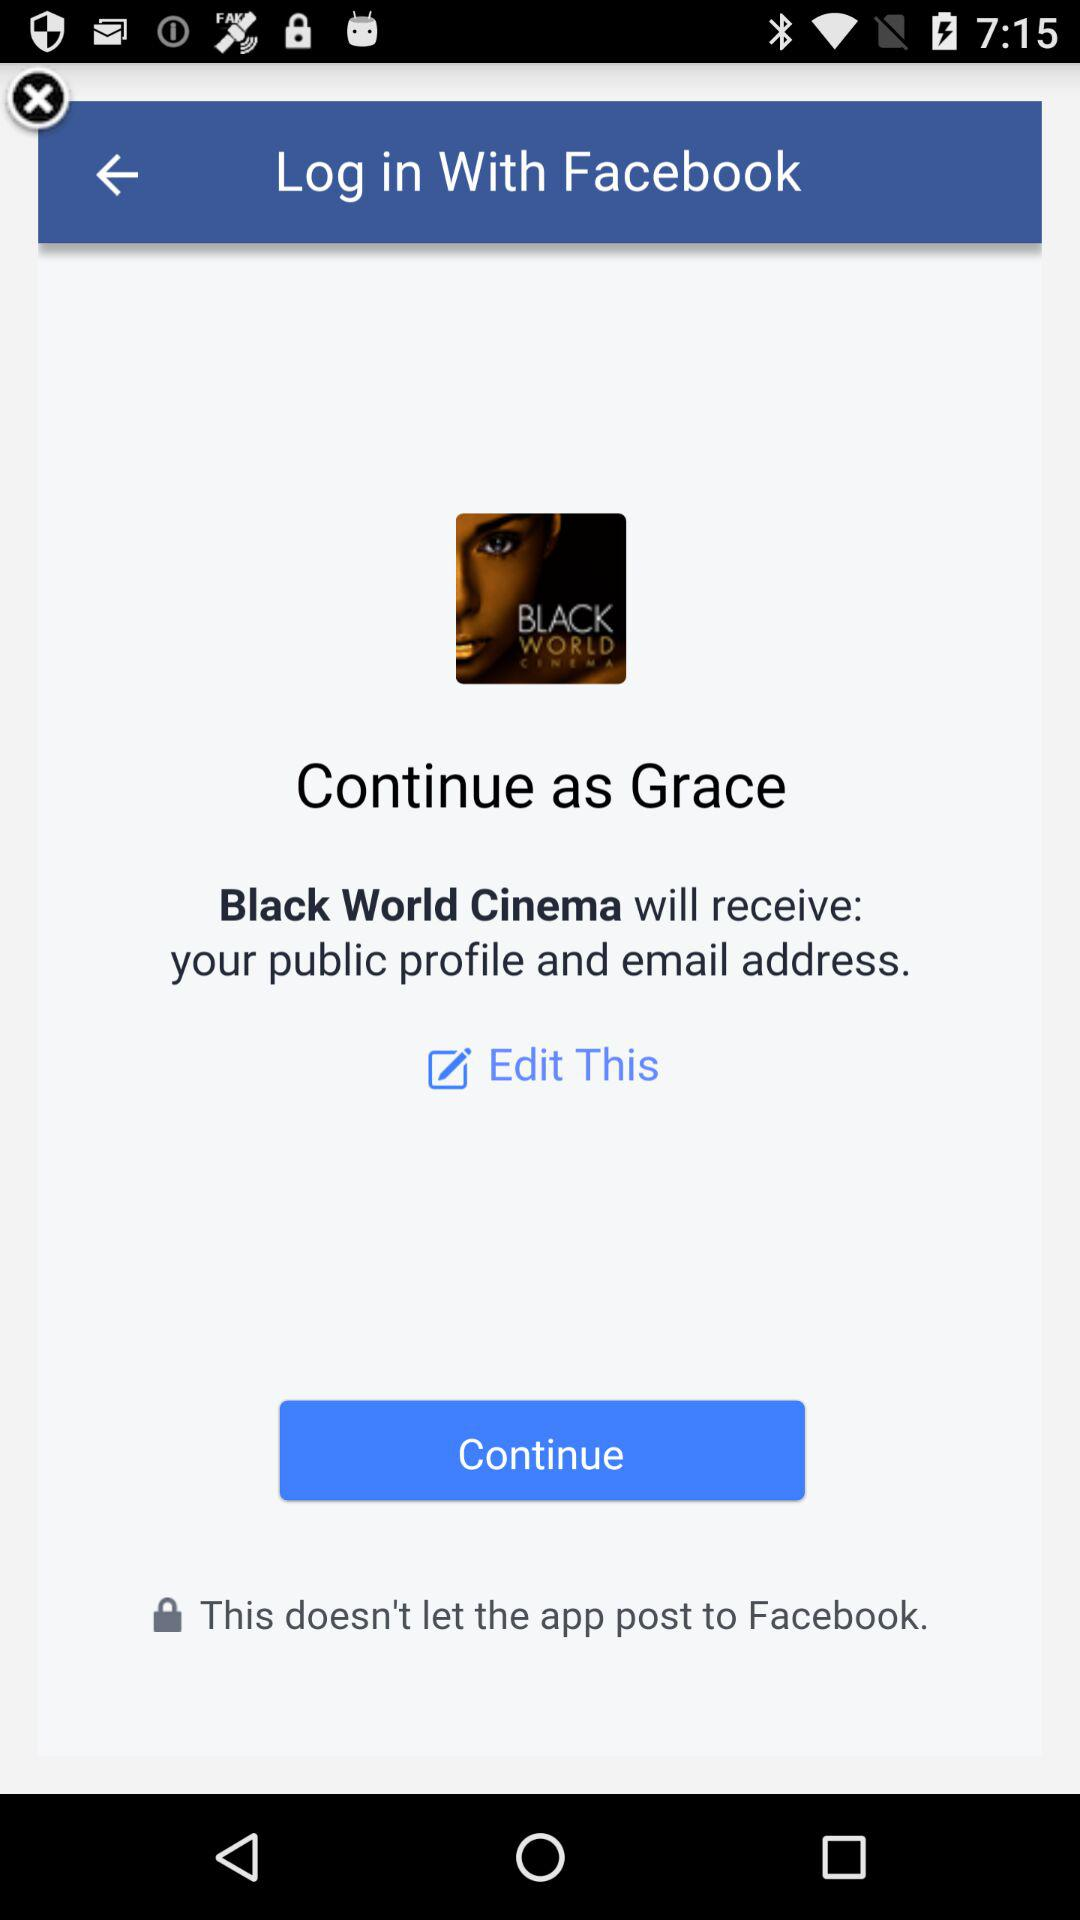What application can be used to log in? The application is "Facebook". 